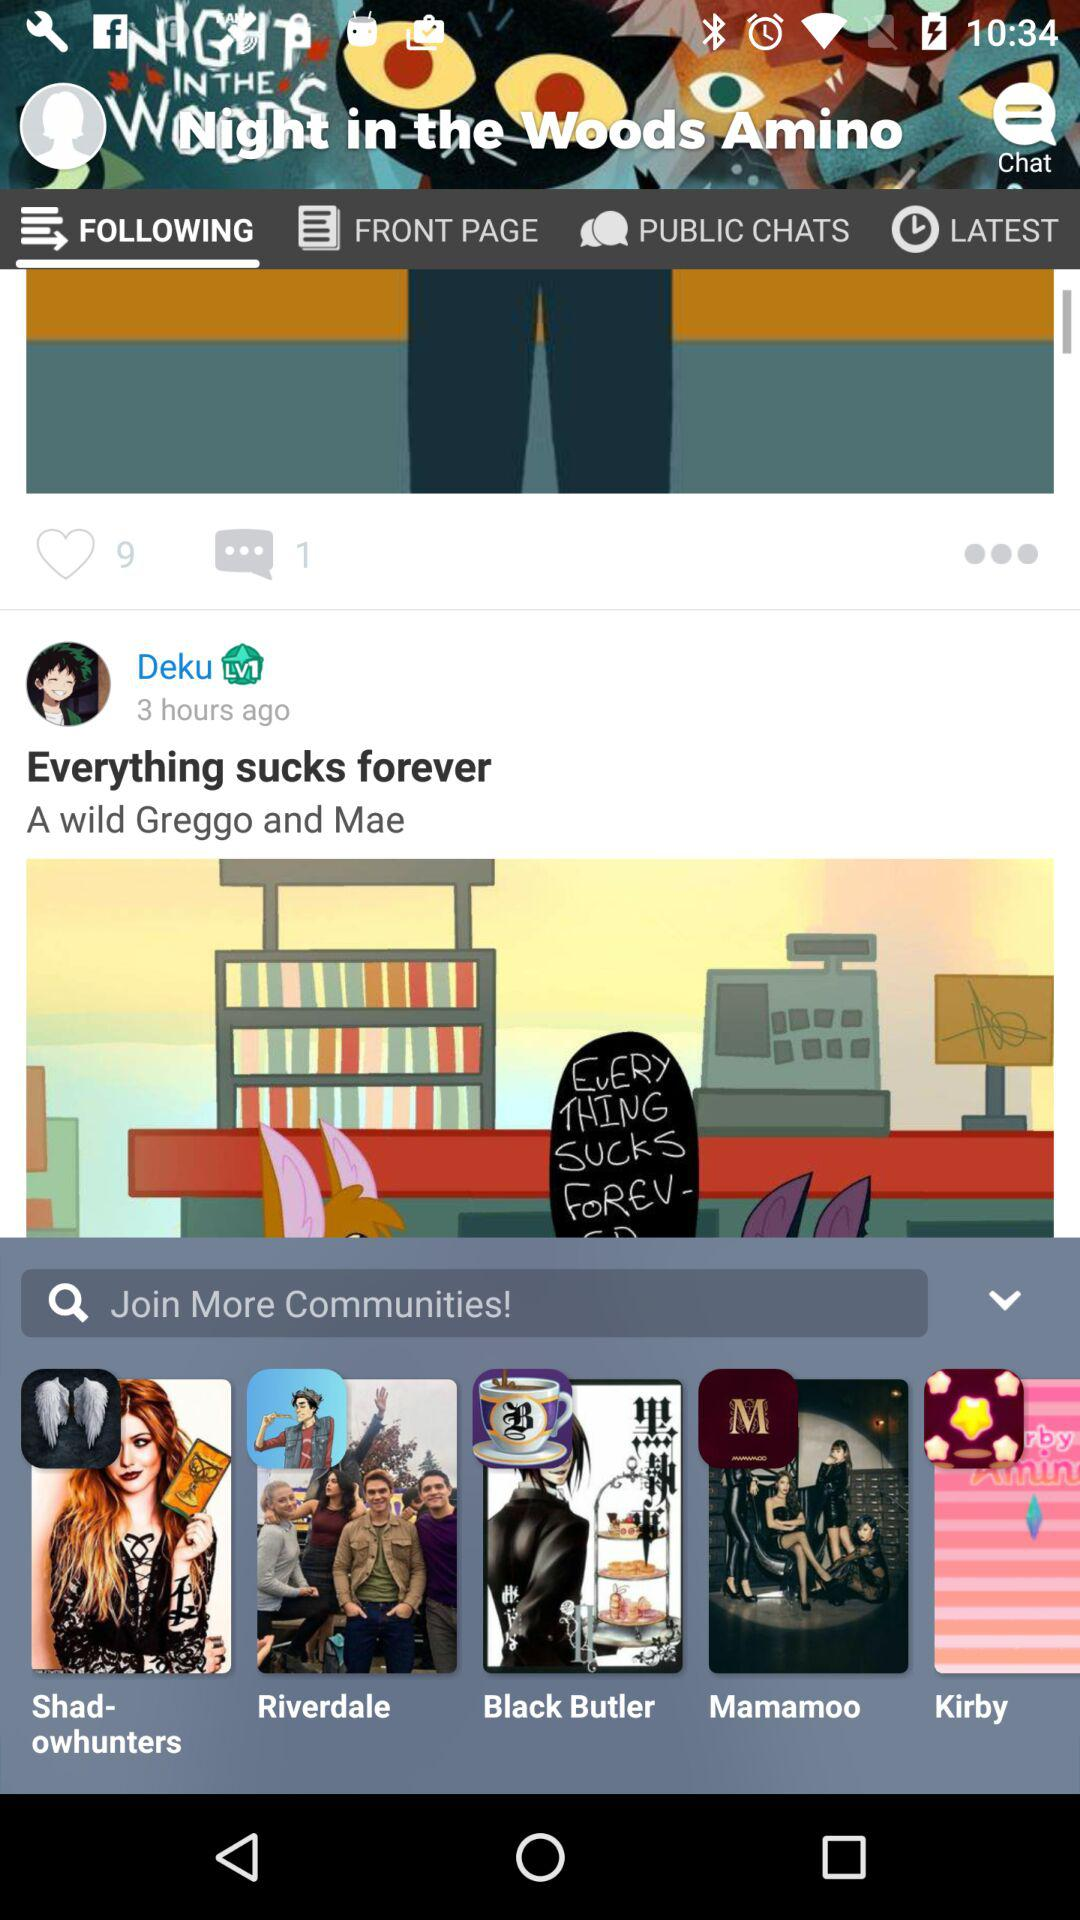How long ago was the post updated by Deku? The post was updated three hours ago. 